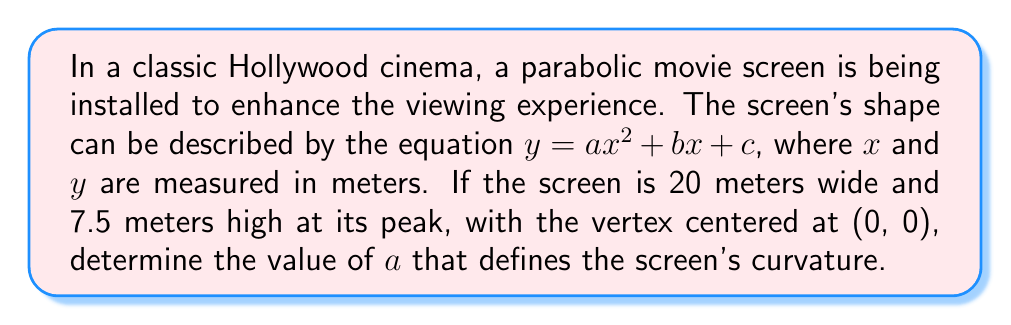What is the answer to this math problem? Let's approach this step-by-step:

1) Given that the vertex is at (0, 0) and the parabola opens upward, we can simplify our equation to:
   $y = ax^2$

2) The screen is 20 meters wide, so it extends 10 meters on each side of the y-axis. At the edge of the screen, x = 10.

3) The height of the screen at its peak (the vertex) is 7.5 meters. So when x = 10, y = 7.5.

4) We can substitute these values into our equation:
   $7.5 = a(10)^2$

5) Simplify:
   $7.5 = 100a$

6) Solve for $a$:
   $a = \frac{7.5}{100} = 0.075$

7) To verify, we can plot the parabola:

[asy]
import graph;
size(200,150);
real f(real x) {return 0.075*x^2;}
draw(graph(f,-10,10),blue);
draw((-10,0)--(10,0),arrow=Arrow(TeXHead));
draw((0,0)--(0,8),arrow=Arrow(TeXHead));
label("x",(10,0),E);
label("y",(0,8),N);
dot((0,0));
dot((10,7.5));
dot((-10,7.5));
label("(0,0)",(0,0),SE);
label("(10,7.5)",(10,7.5),NE);
label("(-10,7.5)",(-10,7.5),NW);
[/asy]

This parabola represents the shape of our movie screen, with the desired width and height.
Answer: $a = 0.075$ 